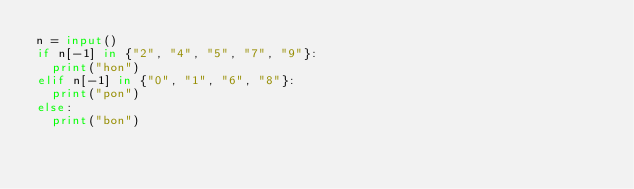<code> <loc_0><loc_0><loc_500><loc_500><_Python_>n = input()
if n[-1] in {"2", "4", "5", "7", "9"}:
  print("hon")
elif n[-1] in {"0", "1", "6", "8"}:
  print("pon")
else:
  print("bon")</code> 